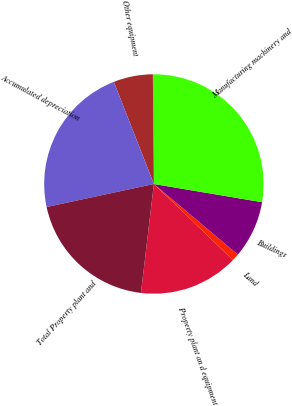Convert chart to OTSL. <chart><loc_0><loc_0><loc_500><loc_500><pie_chart><fcel>Property plant an d equipment<fcel>Land<fcel>Buildings<fcel>Manufacturing machinery and<fcel>Other equipment<fcel>Accumulated depreciation<fcel>Total Property plant and<nl><fcel>14.69%<fcel>1.07%<fcel>8.47%<fcel>27.8%<fcel>5.8%<fcel>22.42%<fcel>19.75%<nl></chart> 